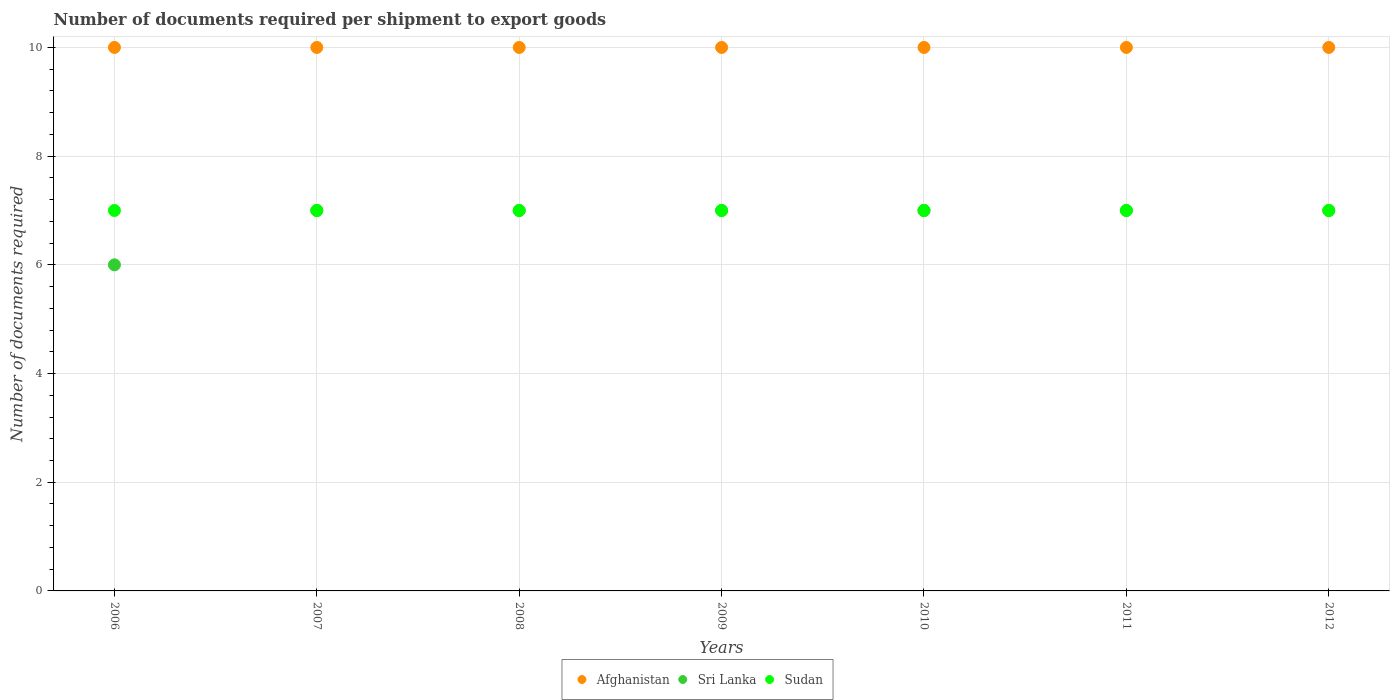How many different coloured dotlines are there?
Ensure brevity in your answer.  3. What is the number of documents required per shipment to export goods in Sudan in 2009?
Provide a short and direct response. 7. Across all years, what is the maximum number of documents required per shipment to export goods in Afghanistan?
Offer a terse response. 10. Across all years, what is the minimum number of documents required per shipment to export goods in Sri Lanka?
Offer a very short reply. 6. What is the total number of documents required per shipment to export goods in Sudan in the graph?
Keep it short and to the point. 49. What is the difference between the number of documents required per shipment to export goods in Sri Lanka in 2006 and that in 2010?
Your answer should be compact. -1. What is the difference between the number of documents required per shipment to export goods in Afghanistan in 2011 and the number of documents required per shipment to export goods in Sri Lanka in 2008?
Your response must be concise. 3. What is the average number of documents required per shipment to export goods in Afghanistan per year?
Your answer should be very brief. 10. In the year 2009, what is the difference between the number of documents required per shipment to export goods in Sri Lanka and number of documents required per shipment to export goods in Afghanistan?
Keep it short and to the point. -3. In how many years, is the number of documents required per shipment to export goods in Sri Lanka greater than 8?
Provide a short and direct response. 0. What is the ratio of the number of documents required per shipment to export goods in Sri Lanka in 2006 to that in 2011?
Provide a short and direct response. 0.86. What is the difference between the highest and the second highest number of documents required per shipment to export goods in Afghanistan?
Provide a short and direct response. 0. In how many years, is the number of documents required per shipment to export goods in Afghanistan greater than the average number of documents required per shipment to export goods in Afghanistan taken over all years?
Ensure brevity in your answer.  0. Is the sum of the number of documents required per shipment to export goods in Sudan in 2008 and 2010 greater than the maximum number of documents required per shipment to export goods in Sri Lanka across all years?
Give a very brief answer. Yes. Is the number of documents required per shipment to export goods in Sudan strictly less than the number of documents required per shipment to export goods in Sri Lanka over the years?
Ensure brevity in your answer.  No. How many dotlines are there?
Give a very brief answer. 3. What is the difference between two consecutive major ticks on the Y-axis?
Your response must be concise. 2. How many legend labels are there?
Keep it short and to the point. 3. What is the title of the graph?
Provide a short and direct response. Number of documents required per shipment to export goods. Does "Low & middle income" appear as one of the legend labels in the graph?
Provide a succinct answer. No. What is the label or title of the Y-axis?
Provide a short and direct response. Number of documents required. What is the Number of documents required of Sri Lanka in 2007?
Your answer should be very brief. 7. What is the Number of documents required in Afghanistan in 2008?
Offer a very short reply. 10. What is the Number of documents required of Sri Lanka in 2008?
Keep it short and to the point. 7. What is the Number of documents required of Sudan in 2008?
Offer a very short reply. 7. What is the Number of documents required of Afghanistan in 2009?
Provide a succinct answer. 10. What is the Number of documents required in Sri Lanka in 2009?
Offer a terse response. 7. What is the Number of documents required of Sudan in 2009?
Your response must be concise. 7. What is the Number of documents required in Sri Lanka in 2010?
Provide a succinct answer. 7. What is the Number of documents required in Sri Lanka in 2011?
Offer a very short reply. 7. What is the Number of documents required in Afghanistan in 2012?
Your answer should be compact. 10. Across all years, what is the minimum Number of documents required of Afghanistan?
Offer a terse response. 10. What is the total Number of documents required in Afghanistan in the graph?
Offer a very short reply. 70. What is the total Number of documents required of Sri Lanka in the graph?
Keep it short and to the point. 48. What is the total Number of documents required of Sudan in the graph?
Keep it short and to the point. 49. What is the difference between the Number of documents required of Sudan in 2006 and that in 2007?
Your response must be concise. 0. What is the difference between the Number of documents required of Sri Lanka in 2006 and that in 2008?
Provide a succinct answer. -1. What is the difference between the Number of documents required of Afghanistan in 2006 and that in 2009?
Give a very brief answer. 0. What is the difference between the Number of documents required of Afghanistan in 2006 and that in 2010?
Offer a very short reply. 0. What is the difference between the Number of documents required of Sri Lanka in 2006 and that in 2010?
Offer a terse response. -1. What is the difference between the Number of documents required of Sri Lanka in 2006 and that in 2011?
Make the answer very short. -1. What is the difference between the Number of documents required in Sudan in 2006 and that in 2011?
Make the answer very short. 0. What is the difference between the Number of documents required of Afghanistan in 2006 and that in 2012?
Give a very brief answer. 0. What is the difference between the Number of documents required in Sri Lanka in 2006 and that in 2012?
Offer a terse response. -1. What is the difference between the Number of documents required in Afghanistan in 2007 and that in 2008?
Your answer should be compact. 0. What is the difference between the Number of documents required in Sri Lanka in 2007 and that in 2008?
Your response must be concise. 0. What is the difference between the Number of documents required in Sudan in 2007 and that in 2008?
Ensure brevity in your answer.  0. What is the difference between the Number of documents required of Sudan in 2007 and that in 2009?
Keep it short and to the point. 0. What is the difference between the Number of documents required of Afghanistan in 2007 and that in 2010?
Keep it short and to the point. 0. What is the difference between the Number of documents required in Sri Lanka in 2007 and that in 2010?
Your answer should be compact. 0. What is the difference between the Number of documents required in Sri Lanka in 2007 and that in 2012?
Offer a very short reply. 0. What is the difference between the Number of documents required in Afghanistan in 2008 and that in 2009?
Offer a terse response. 0. What is the difference between the Number of documents required in Sri Lanka in 2008 and that in 2009?
Your answer should be compact. 0. What is the difference between the Number of documents required of Afghanistan in 2008 and that in 2010?
Provide a succinct answer. 0. What is the difference between the Number of documents required in Sri Lanka in 2008 and that in 2010?
Provide a succinct answer. 0. What is the difference between the Number of documents required of Sudan in 2008 and that in 2010?
Give a very brief answer. 0. What is the difference between the Number of documents required in Sri Lanka in 2008 and that in 2011?
Your answer should be very brief. 0. What is the difference between the Number of documents required in Sudan in 2008 and that in 2012?
Your response must be concise. 0. What is the difference between the Number of documents required in Afghanistan in 2009 and that in 2010?
Ensure brevity in your answer.  0. What is the difference between the Number of documents required in Sri Lanka in 2009 and that in 2010?
Make the answer very short. 0. What is the difference between the Number of documents required in Afghanistan in 2009 and that in 2011?
Your answer should be very brief. 0. What is the difference between the Number of documents required in Sudan in 2009 and that in 2011?
Offer a terse response. 0. What is the difference between the Number of documents required in Afghanistan in 2009 and that in 2012?
Make the answer very short. 0. What is the difference between the Number of documents required in Sudan in 2009 and that in 2012?
Make the answer very short. 0. What is the difference between the Number of documents required in Sudan in 2010 and that in 2011?
Make the answer very short. 0. What is the difference between the Number of documents required of Afghanistan in 2010 and that in 2012?
Your answer should be compact. 0. What is the difference between the Number of documents required of Sri Lanka in 2010 and that in 2012?
Provide a succinct answer. 0. What is the difference between the Number of documents required of Afghanistan in 2011 and that in 2012?
Offer a very short reply. 0. What is the difference between the Number of documents required in Sri Lanka in 2006 and the Number of documents required in Sudan in 2008?
Your response must be concise. -1. What is the difference between the Number of documents required of Sri Lanka in 2006 and the Number of documents required of Sudan in 2009?
Offer a terse response. -1. What is the difference between the Number of documents required of Afghanistan in 2006 and the Number of documents required of Sudan in 2010?
Your response must be concise. 3. What is the difference between the Number of documents required of Afghanistan in 2006 and the Number of documents required of Sri Lanka in 2011?
Keep it short and to the point. 3. What is the difference between the Number of documents required of Afghanistan in 2006 and the Number of documents required of Sudan in 2012?
Offer a terse response. 3. What is the difference between the Number of documents required in Afghanistan in 2007 and the Number of documents required in Sudan in 2008?
Keep it short and to the point. 3. What is the difference between the Number of documents required in Sri Lanka in 2007 and the Number of documents required in Sudan in 2008?
Offer a very short reply. 0. What is the difference between the Number of documents required in Sri Lanka in 2007 and the Number of documents required in Sudan in 2009?
Keep it short and to the point. 0. What is the difference between the Number of documents required in Afghanistan in 2007 and the Number of documents required in Sudan in 2010?
Make the answer very short. 3. What is the difference between the Number of documents required in Sri Lanka in 2007 and the Number of documents required in Sudan in 2010?
Make the answer very short. 0. What is the difference between the Number of documents required in Afghanistan in 2007 and the Number of documents required in Sri Lanka in 2011?
Provide a succinct answer. 3. What is the difference between the Number of documents required in Afghanistan in 2007 and the Number of documents required in Sudan in 2011?
Your response must be concise. 3. What is the difference between the Number of documents required of Sri Lanka in 2007 and the Number of documents required of Sudan in 2011?
Offer a terse response. 0. What is the difference between the Number of documents required of Sri Lanka in 2007 and the Number of documents required of Sudan in 2012?
Offer a very short reply. 0. What is the difference between the Number of documents required in Afghanistan in 2008 and the Number of documents required in Sri Lanka in 2009?
Ensure brevity in your answer.  3. What is the difference between the Number of documents required of Afghanistan in 2008 and the Number of documents required of Sudan in 2009?
Ensure brevity in your answer.  3. What is the difference between the Number of documents required of Afghanistan in 2008 and the Number of documents required of Sudan in 2010?
Your answer should be very brief. 3. What is the difference between the Number of documents required in Afghanistan in 2008 and the Number of documents required in Sudan in 2011?
Keep it short and to the point. 3. What is the difference between the Number of documents required of Sri Lanka in 2008 and the Number of documents required of Sudan in 2011?
Provide a short and direct response. 0. What is the difference between the Number of documents required of Afghanistan in 2008 and the Number of documents required of Sri Lanka in 2012?
Your response must be concise. 3. What is the difference between the Number of documents required of Afghanistan in 2008 and the Number of documents required of Sudan in 2012?
Offer a terse response. 3. What is the difference between the Number of documents required in Sri Lanka in 2008 and the Number of documents required in Sudan in 2012?
Your answer should be compact. 0. What is the difference between the Number of documents required in Afghanistan in 2009 and the Number of documents required in Sudan in 2011?
Give a very brief answer. 3. What is the difference between the Number of documents required of Afghanistan in 2009 and the Number of documents required of Sri Lanka in 2012?
Offer a terse response. 3. What is the difference between the Number of documents required in Afghanistan in 2009 and the Number of documents required in Sudan in 2012?
Ensure brevity in your answer.  3. What is the difference between the Number of documents required of Sri Lanka in 2010 and the Number of documents required of Sudan in 2011?
Your answer should be very brief. 0. What is the difference between the Number of documents required in Afghanistan in 2010 and the Number of documents required in Sri Lanka in 2012?
Provide a short and direct response. 3. What is the difference between the Number of documents required in Sri Lanka in 2011 and the Number of documents required in Sudan in 2012?
Make the answer very short. 0. What is the average Number of documents required of Afghanistan per year?
Provide a short and direct response. 10. What is the average Number of documents required of Sri Lanka per year?
Make the answer very short. 6.86. What is the average Number of documents required of Sudan per year?
Make the answer very short. 7. In the year 2006, what is the difference between the Number of documents required in Afghanistan and Number of documents required in Sudan?
Give a very brief answer. 3. In the year 2007, what is the difference between the Number of documents required in Afghanistan and Number of documents required in Sri Lanka?
Provide a succinct answer. 3. In the year 2008, what is the difference between the Number of documents required in Afghanistan and Number of documents required in Sri Lanka?
Ensure brevity in your answer.  3. In the year 2008, what is the difference between the Number of documents required of Sri Lanka and Number of documents required of Sudan?
Provide a succinct answer. 0. In the year 2009, what is the difference between the Number of documents required of Afghanistan and Number of documents required of Sri Lanka?
Keep it short and to the point. 3. In the year 2009, what is the difference between the Number of documents required in Sri Lanka and Number of documents required in Sudan?
Your response must be concise. 0. In the year 2010, what is the difference between the Number of documents required of Afghanistan and Number of documents required of Sri Lanka?
Make the answer very short. 3. In the year 2011, what is the difference between the Number of documents required of Afghanistan and Number of documents required of Sri Lanka?
Make the answer very short. 3. In the year 2011, what is the difference between the Number of documents required of Afghanistan and Number of documents required of Sudan?
Offer a terse response. 3. In the year 2011, what is the difference between the Number of documents required of Sri Lanka and Number of documents required of Sudan?
Ensure brevity in your answer.  0. In the year 2012, what is the difference between the Number of documents required of Sri Lanka and Number of documents required of Sudan?
Make the answer very short. 0. What is the ratio of the Number of documents required in Afghanistan in 2006 to that in 2007?
Offer a very short reply. 1. What is the ratio of the Number of documents required in Sri Lanka in 2006 to that in 2007?
Offer a terse response. 0.86. What is the ratio of the Number of documents required in Afghanistan in 2006 to that in 2009?
Your answer should be compact. 1. What is the ratio of the Number of documents required in Sri Lanka in 2006 to that in 2010?
Offer a terse response. 0.86. What is the ratio of the Number of documents required of Afghanistan in 2006 to that in 2012?
Offer a very short reply. 1. What is the ratio of the Number of documents required in Sri Lanka in 2006 to that in 2012?
Your answer should be compact. 0.86. What is the ratio of the Number of documents required in Sudan in 2006 to that in 2012?
Make the answer very short. 1. What is the ratio of the Number of documents required of Sudan in 2007 to that in 2008?
Offer a terse response. 1. What is the ratio of the Number of documents required in Afghanistan in 2007 to that in 2009?
Your response must be concise. 1. What is the ratio of the Number of documents required in Sri Lanka in 2007 to that in 2009?
Keep it short and to the point. 1. What is the ratio of the Number of documents required in Afghanistan in 2007 to that in 2011?
Make the answer very short. 1. What is the ratio of the Number of documents required of Sri Lanka in 2007 to that in 2011?
Keep it short and to the point. 1. What is the ratio of the Number of documents required of Afghanistan in 2007 to that in 2012?
Make the answer very short. 1. What is the ratio of the Number of documents required of Sri Lanka in 2007 to that in 2012?
Keep it short and to the point. 1. What is the ratio of the Number of documents required of Sudan in 2007 to that in 2012?
Offer a terse response. 1. What is the ratio of the Number of documents required of Afghanistan in 2008 to that in 2009?
Keep it short and to the point. 1. What is the ratio of the Number of documents required of Sri Lanka in 2008 to that in 2009?
Keep it short and to the point. 1. What is the ratio of the Number of documents required in Sudan in 2008 to that in 2009?
Make the answer very short. 1. What is the ratio of the Number of documents required of Afghanistan in 2008 to that in 2010?
Your response must be concise. 1. What is the ratio of the Number of documents required in Sri Lanka in 2008 to that in 2011?
Provide a succinct answer. 1. What is the ratio of the Number of documents required of Sudan in 2008 to that in 2011?
Your answer should be very brief. 1. What is the ratio of the Number of documents required of Sudan in 2008 to that in 2012?
Keep it short and to the point. 1. What is the ratio of the Number of documents required of Sudan in 2009 to that in 2010?
Keep it short and to the point. 1. What is the ratio of the Number of documents required in Afghanistan in 2009 to that in 2011?
Provide a succinct answer. 1. What is the ratio of the Number of documents required of Sudan in 2009 to that in 2011?
Give a very brief answer. 1. What is the ratio of the Number of documents required in Afghanistan in 2009 to that in 2012?
Provide a short and direct response. 1. What is the ratio of the Number of documents required of Sri Lanka in 2009 to that in 2012?
Keep it short and to the point. 1. What is the ratio of the Number of documents required of Sudan in 2009 to that in 2012?
Give a very brief answer. 1. What is the ratio of the Number of documents required in Sri Lanka in 2010 to that in 2011?
Your response must be concise. 1. What is the ratio of the Number of documents required of Sudan in 2010 to that in 2011?
Make the answer very short. 1. What is the ratio of the Number of documents required in Sudan in 2010 to that in 2012?
Offer a terse response. 1. What is the ratio of the Number of documents required in Afghanistan in 2011 to that in 2012?
Your answer should be very brief. 1. What is the difference between the highest and the second highest Number of documents required of Sri Lanka?
Give a very brief answer. 0. What is the difference between the highest and the lowest Number of documents required in Sri Lanka?
Ensure brevity in your answer.  1. What is the difference between the highest and the lowest Number of documents required of Sudan?
Your response must be concise. 0. 